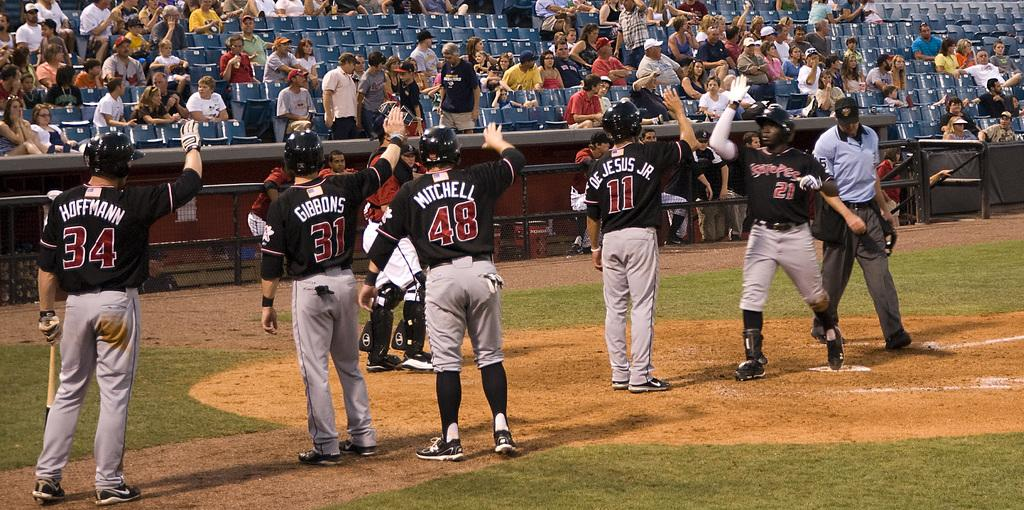<image>
Relay a brief, clear account of the picture shown. Some men on a sports field, a man wearing number 48 towards the back . 